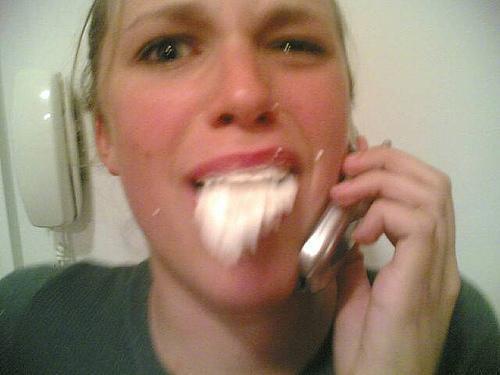How many people are shown?
Give a very brief answer. 1. How many eyes are visible?
Give a very brief answer. 2. How many of the person's hands are visible?
Give a very brief answer. 1. How many phones are to the right of the woman?
Give a very brief answer. 1. 